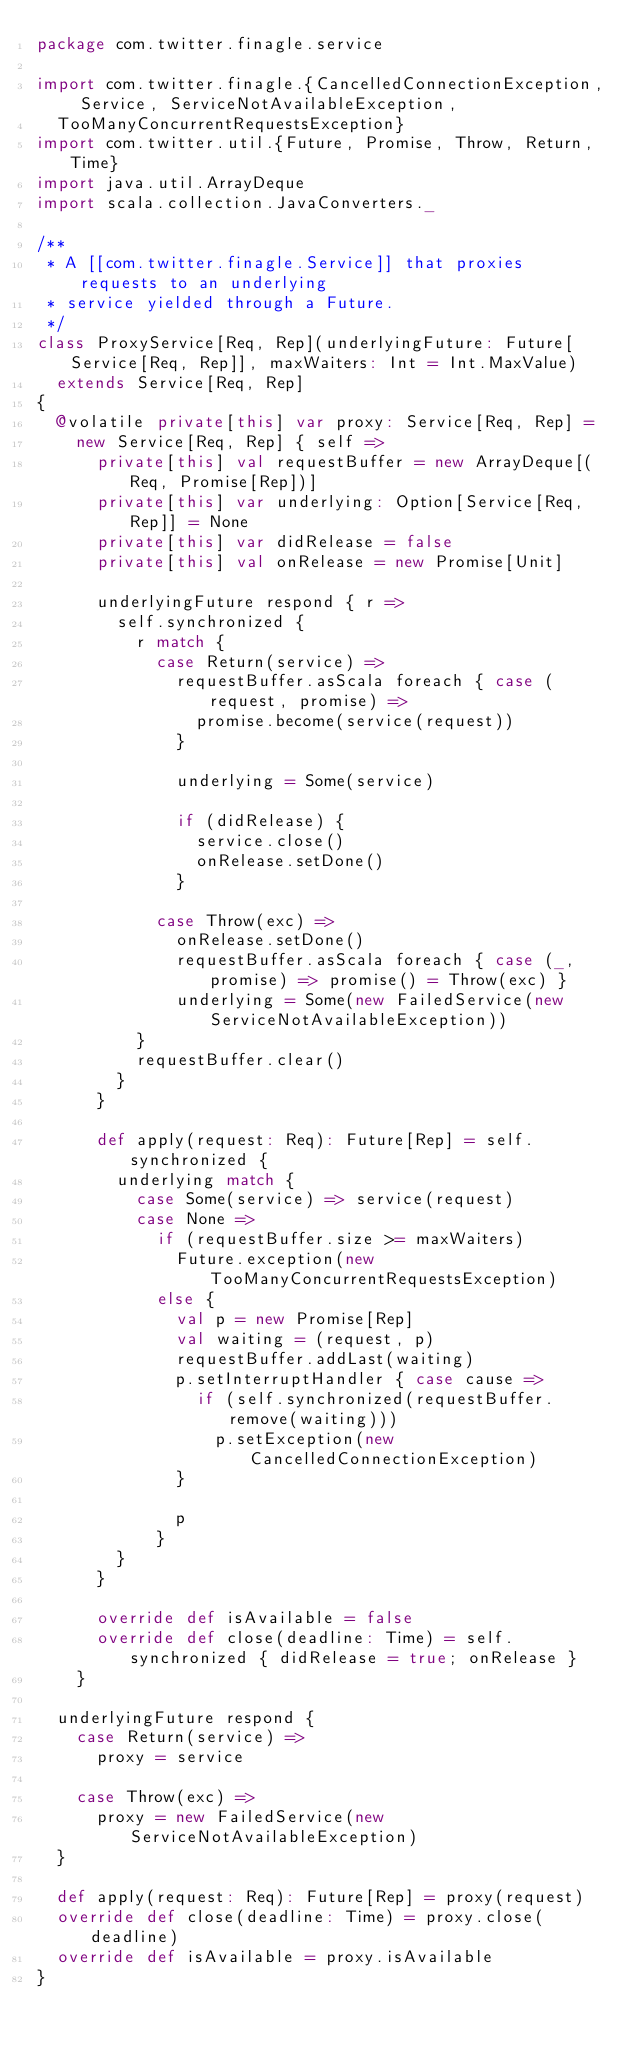<code> <loc_0><loc_0><loc_500><loc_500><_Scala_>package com.twitter.finagle.service

import com.twitter.finagle.{CancelledConnectionException, Service, ServiceNotAvailableException,
  TooManyConcurrentRequestsException}
import com.twitter.util.{Future, Promise, Throw, Return, Time}
import java.util.ArrayDeque
import scala.collection.JavaConverters._

/**
 * A [[com.twitter.finagle.Service]] that proxies requests to an underlying
 * service yielded through a Future.
 */
class ProxyService[Req, Rep](underlyingFuture: Future[Service[Req, Rep]], maxWaiters: Int = Int.MaxValue)
  extends Service[Req, Rep]
{
  @volatile private[this] var proxy: Service[Req, Rep] =
    new Service[Req, Rep] { self =>
      private[this] val requestBuffer = new ArrayDeque[(Req, Promise[Rep])]
      private[this] var underlying: Option[Service[Req, Rep]] = None
      private[this] var didRelease = false
      private[this] val onRelease = new Promise[Unit]

      underlyingFuture respond { r =>
        self.synchronized {
          r match {
            case Return(service) =>
              requestBuffer.asScala foreach { case (request, promise) =>
                promise.become(service(request))
              }

              underlying = Some(service)

              if (didRelease) {
                service.close()
                onRelease.setDone()
              }

            case Throw(exc) =>
              onRelease.setDone()
              requestBuffer.asScala foreach { case (_, promise) => promise() = Throw(exc) }
              underlying = Some(new FailedService(new ServiceNotAvailableException))
          }
          requestBuffer.clear()
        }
      }

      def apply(request: Req): Future[Rep] = self.synchronized {
        underlying match {
          case Some(service) => service(request)
          case None =>
            if (requestBuffer.size >= maxWaiters)
              Future.exception(new TooManyConcurrentRequestsException)
            else {
              val p = new Promise[Rep]
              val waiting = (request, p)
              requestBuffer.addLast(waiting)
              p.setInterruptHandler { case cause =>
                if (self.synchronized(requestBuffer.remove(waiting)))
                  p.setException(new CancelledConnectionException)
              }

              p
            }
        }
      }

      override def isAvailable = false
      override def close(deadline: Time) = self.synchronized { didRelease = true; onRelease }
    }

  underlyingFuture respond {
    case Return(service) =>
      proxy = service

    case Throw(exc) =>
      proxy = new FailedService(new ServiceNotAvailableException)
  }

  def apply(request: Req): Future[Rep] = proxy(request)
  override def close(deadline: Time) = proxy.close(deadline)
  override def isAvailable = proxy.isAvailable
}
</code> 